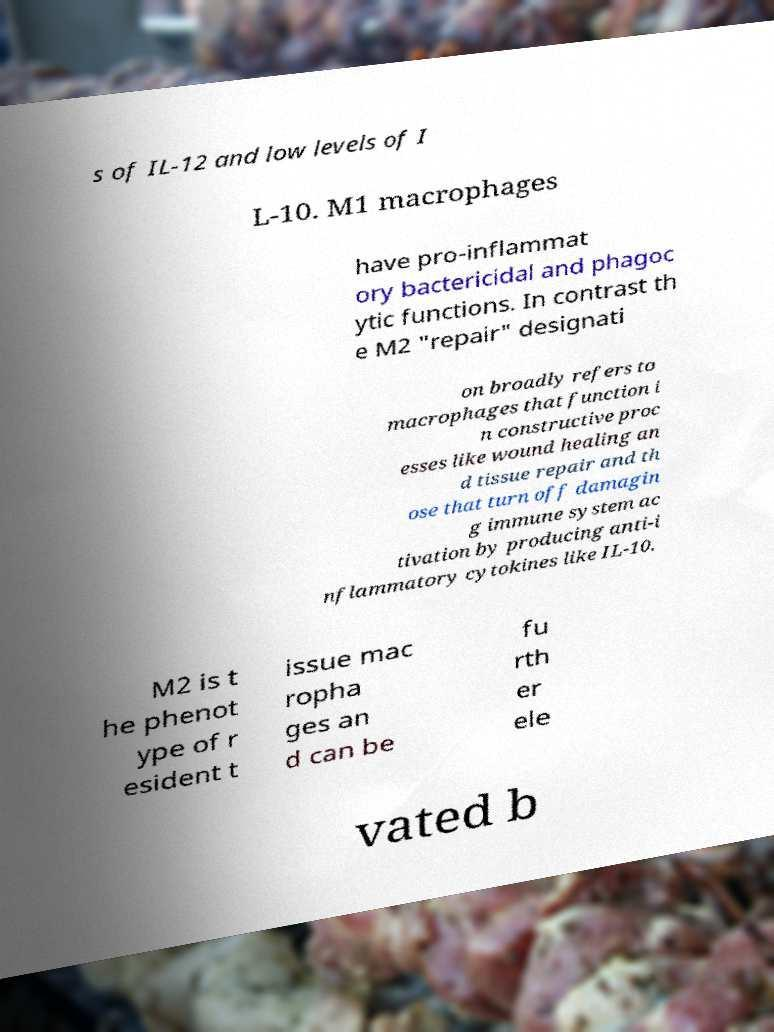Please identify and transcribe the text found in this image. s of IL-12 and low levels of I L-10. M1 macrophages have pro-inflammat ory bactericidal and phagoc ytic functions. In contrast th e M2 "repair" designati on broadly refers to macrophages that function i n constructive proc esses like wound healing an d tissue repair and th ose that turn off damagin g immune system ac tivation by producing anti-i nflammatory cytokines like IL-10. M2 is t he phenot ype of r esident t issue mac ropha ges an d can be fu rth er ele vated b 